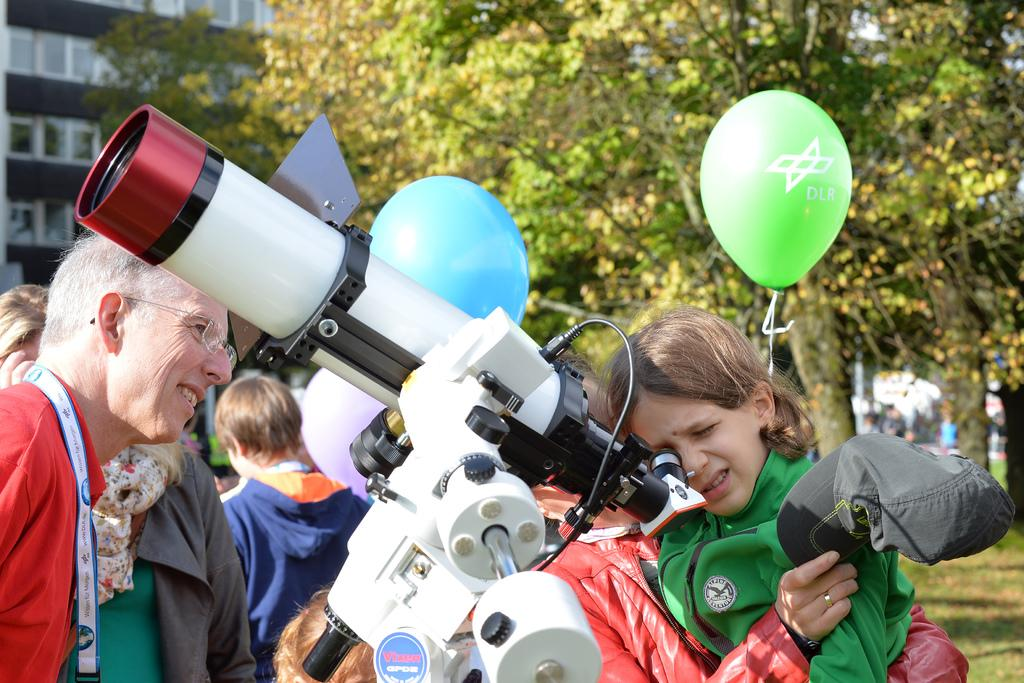What type of structure is visible in the image? There is a building in the image. What can be seen in the background of the image? There are trees in the image. Are there any people present in the image? Yes, there are people standing in the image. What object is used for observing distant objects in the image? There is a telescope in the image. What additional decorative items are present in the image? There are balloons in the image. What type of ground surface is visible in the image? There is grass on the ground in the image. What songs are being sung by the elbow in the image? There is no mention of singing or elbows in the image; it features a building, trees, people, a telescope, balloons, and grass. 